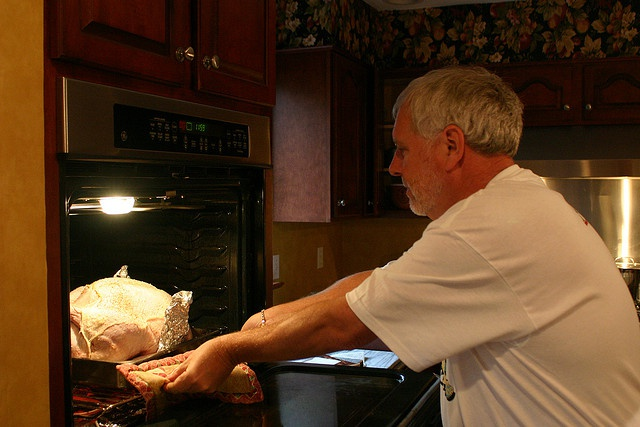Describe the objects in this image and their specific colors. I can see people in brown, tan, gray, and maroon tones, oven in brown, black, khaki, and maroon tones, and bird in brown, khaki, lightyellow, and orange tones in this image. 